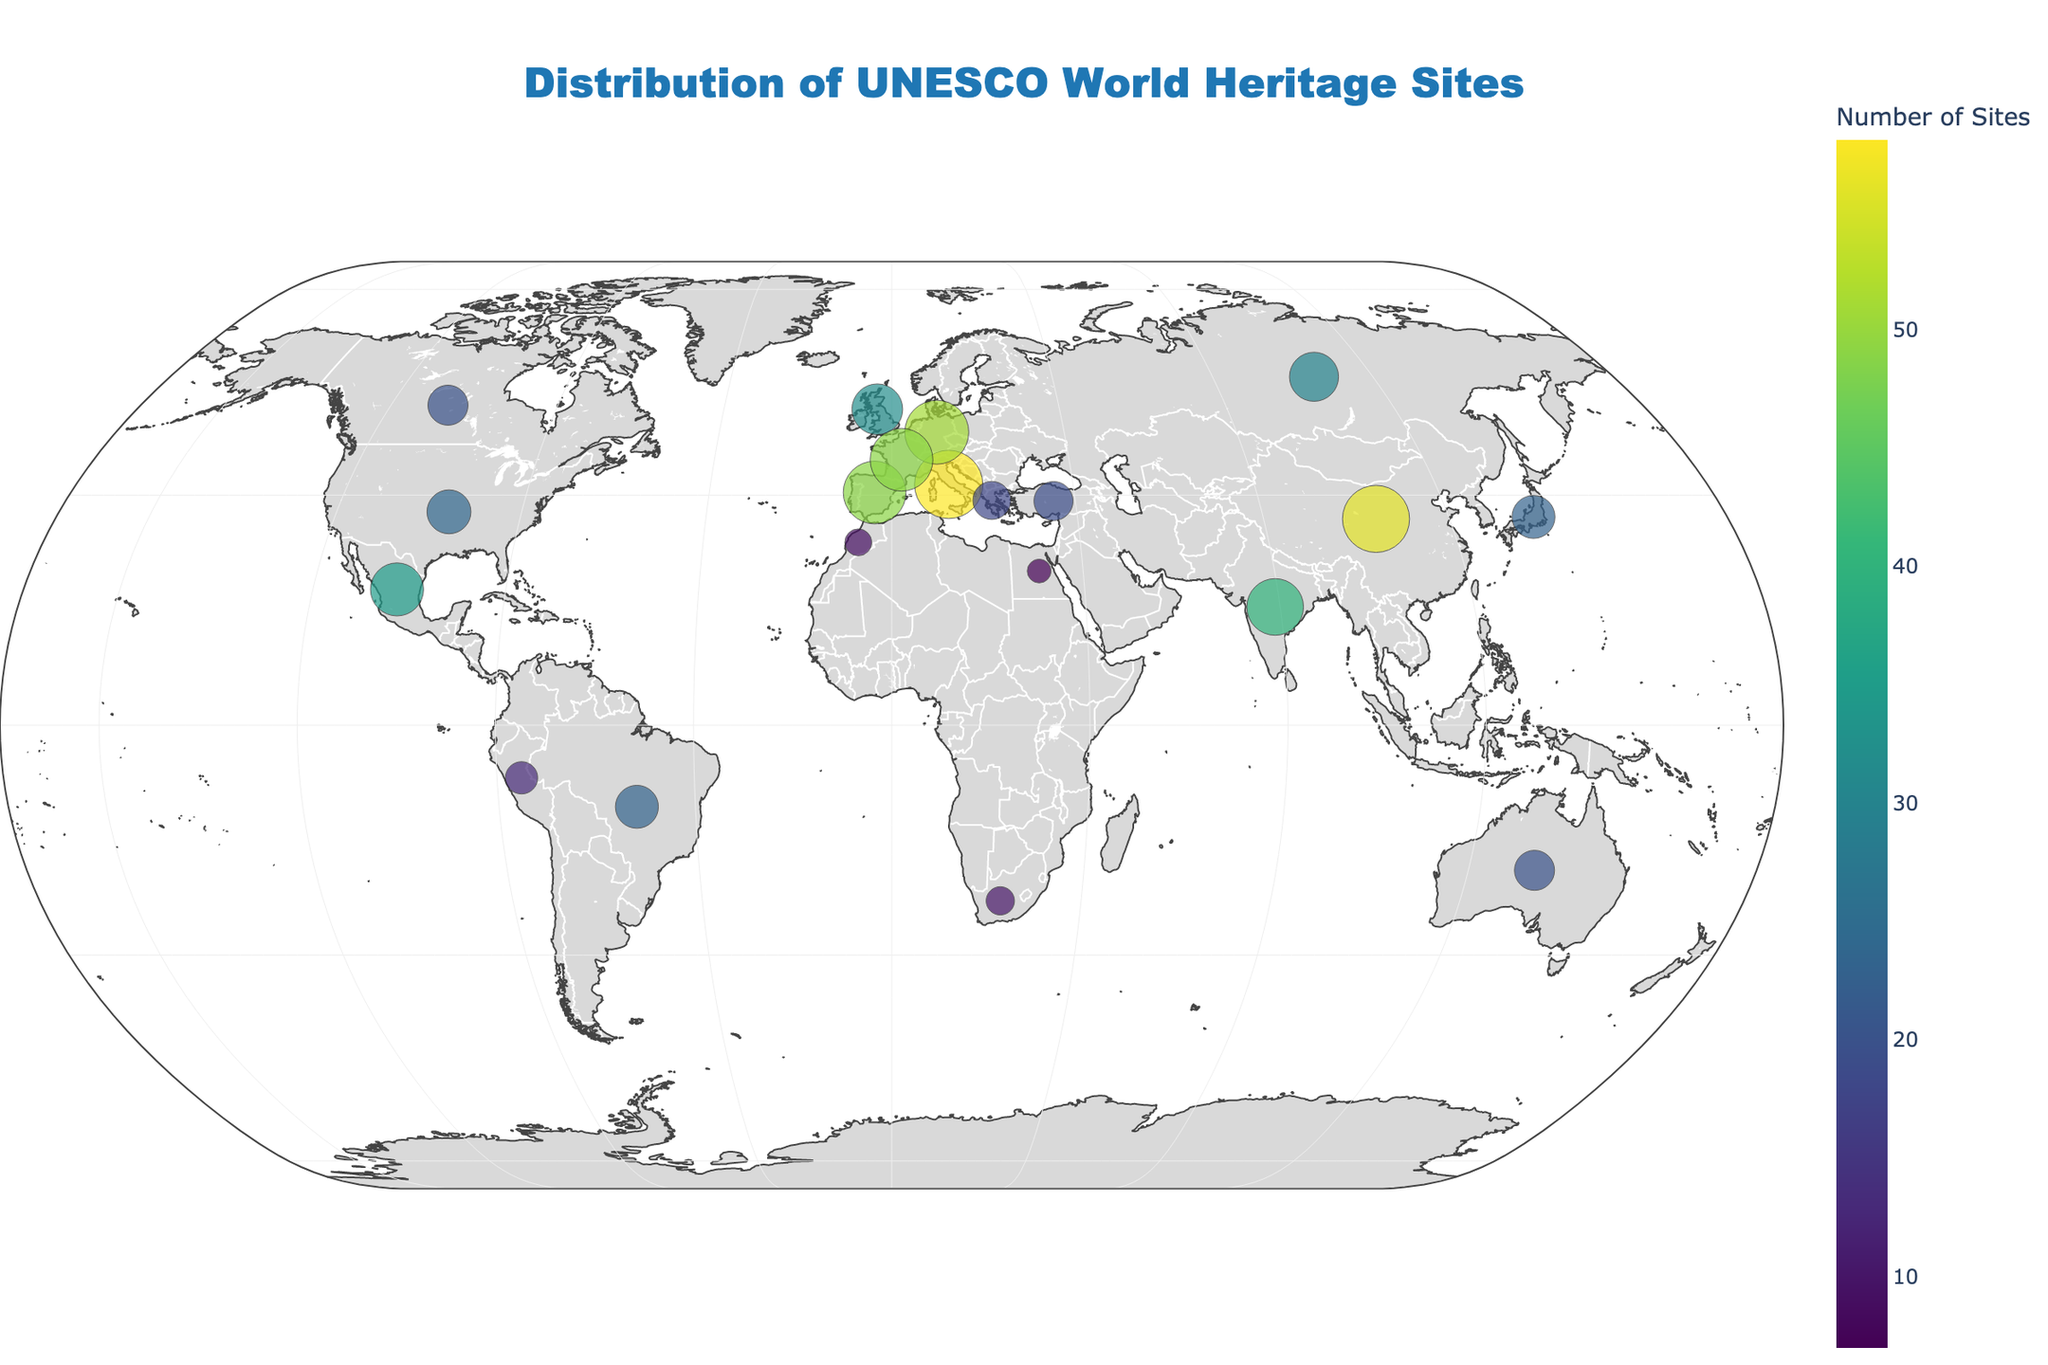What is the title of the plot? The title of the plot is located at the top center of the figure, right above the map. The text is styled in a large, bold font.
Answer: Distribution of UNESCO World Heritage Sites Which country has the highest number of UNESCO World Heritage Sites? By looking at the size of the markers and the color gradient, we can identify the country with the maximum values. The largest and most intensely colored marker corresponds to the country with the highest number of sites.
Answer: Italy How many countries are depicted in the plot? Each distinct marker on the plot represents a different country. By counting these markers, we can determine the number of countries shown.
Answer: 20 What is the color of the markers representing the number of sites, and how is it related to the number of sites? The plot utilizes a color scale to represent the number of sites. Markers with more sites have more intense colors, as indicated by the color bar on the right side of the plot.
Answer: Color ranges from light to dark depending on site count Between China and India, which country has more UNESCO World Heritage Sites? By locating the markers for China and India on the map and comparing their sizes and shades, we can determine which country has more sites.
Answer: China What general geographic area appears to have the highest concentration of UNESCO World Heritage Sites? By observing where the largest and most intensely colored markers are clustered, we can infer the general geographic area.
Answer: Europe What's the sum of UNESCO World Heritage Sites in the United States, Japan, and Brazil? Add the number of sites in the United States (24), Japan (23), and Brazil (23).
Answer: 70 Which country in Africa has the most UNESCO World Heritage Sites, and how many? Identify the markers located in Africa and compare their sizes and colors to find the country with the most sites.
Answer: South Africa, 10 What is the total number of UNESCO World Heritage Sites depicted in the plot? Sum the 'Number of Sites' for all the countries shown on the plot. Calculating the total: 58 + 56 + 49 + 51 + 49 + 40 + 35 + 32 + 30 + 24 + 23 + 23 + 20 + 20 + 18 + 7 + 13 + 19 + 9 + 10.
Answer: 588 Which countries have the same number of UNESCO World Heritage Sites, and how many sites do they have? Look for markers of equal size and color on the plot, noting their corresponding countries.
Answer: France and Spain, each with 49 sites 